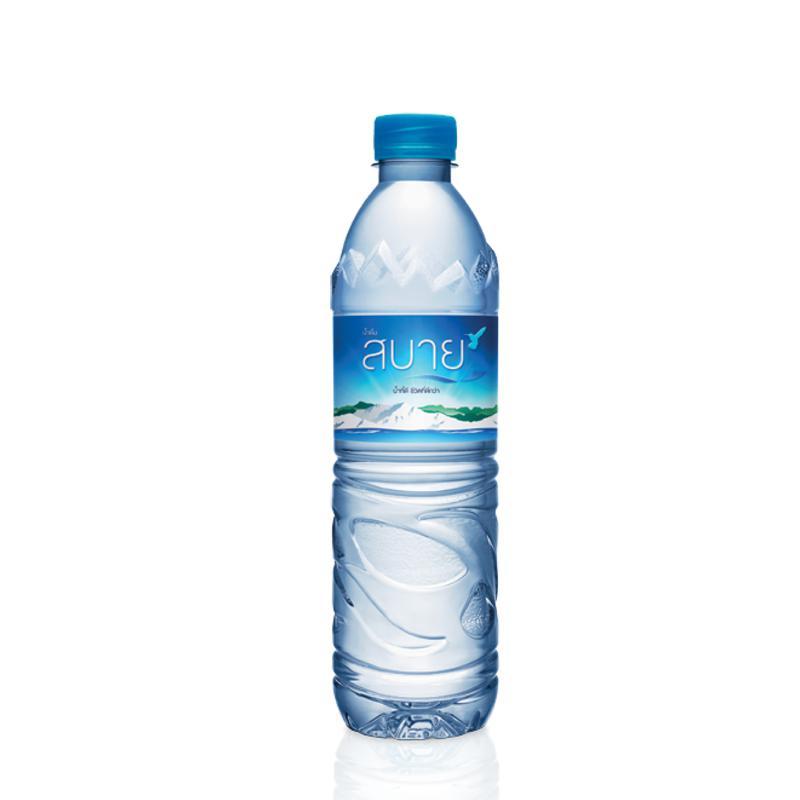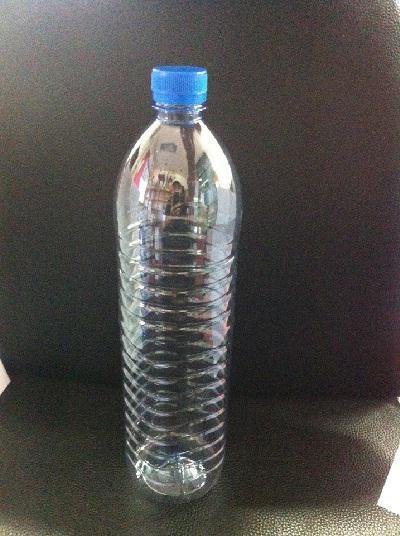The first image is the image on the left, the second image is the image on the right. Considering the images on both sides, is "The bottle caps are all blue." valid? Answer yes or no. Yes. The first image is the image on the left, the second image is the image on the right. Considering the images on both sides, is "There is a reusable water bottle on the left and a disposable bottle on the right." valid? Answer yes or no. No. 